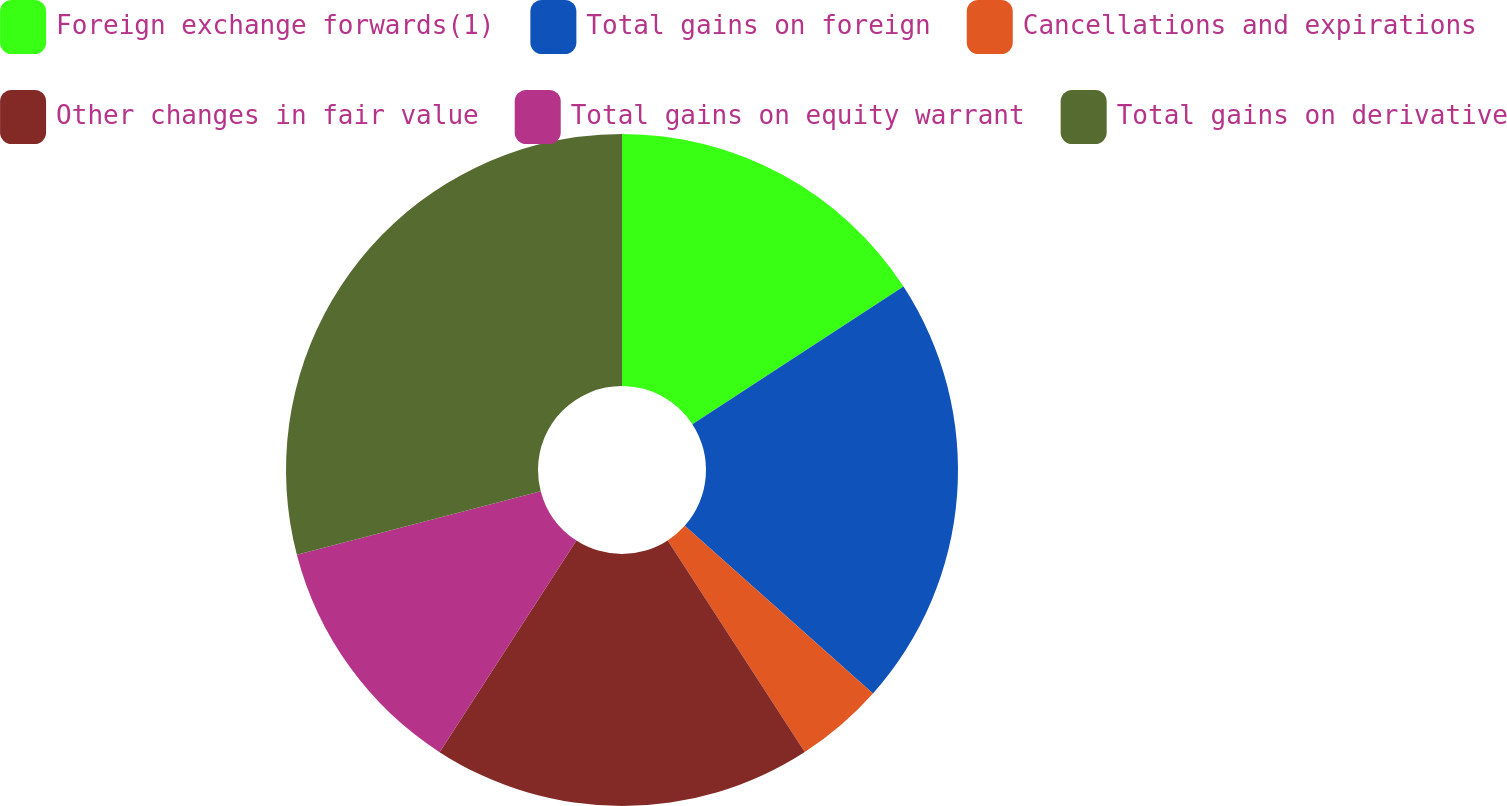<chart> <loc_0><loc_0><loc_500><loc_500><pie_chart><fcel>Foreign exchange forwards(1)<fcel>Total gains on foreign<fcel>Cancellations and expirations<fcel>Other changes in fair value<fcel>Total gains on equity warrant<fcel>Total gains on derivative<nl><fcel>15.81%<fcel>20.77%<fcel>4.27%<fcel>18.29%<fcel>11.81%<fcel>29.06%<nl></chart> 